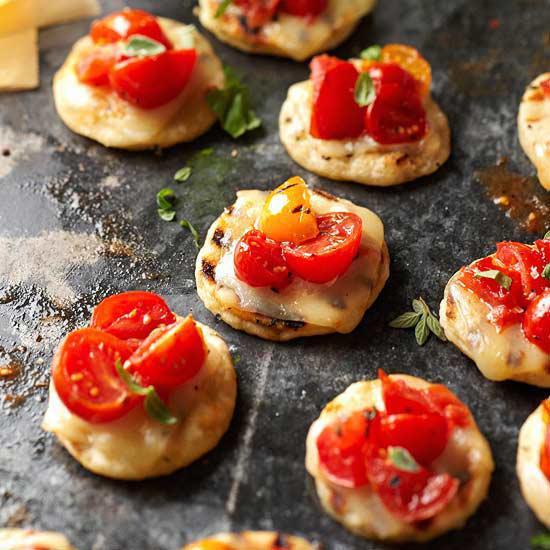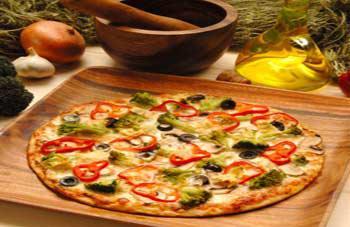The first image is the image on the left, the second image is the image on the right. For the images displayed, is the sentence "A sign on the chalkboard is announcing the food on the table in one of the images." factually correct? Answer yes or no. No. The first image is the image on the left, the second image is the image on the right. For the images shown, is this caption "In the image on the right, some pizzas are raised on stands." true? Answer yes or no. No. 